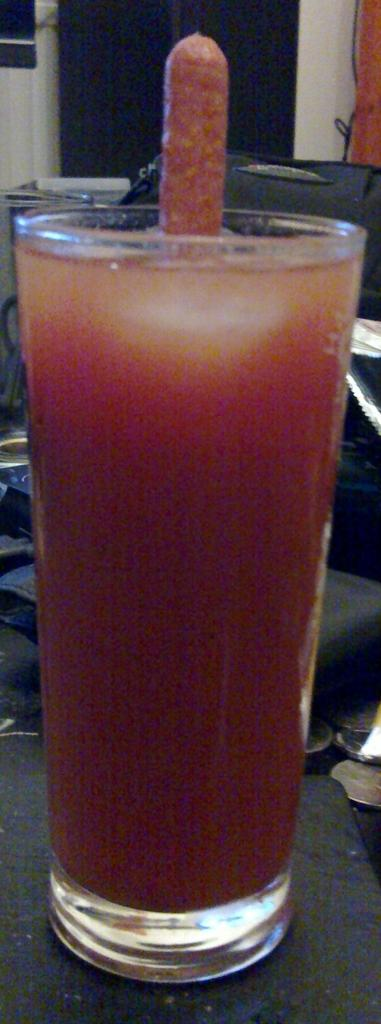What piece of furniture is present in the image? There is a table in the image. What is placed on the table? There is a glass on the table. What is inside the glass? The glass contains juice. What can be seen in the background of the image? There are chairs in the background of the image. What invention is being demonstrated in the image? There is no invention being demonstrated in the image; it simply shows a table with a glass of juice and chairs in the background. 